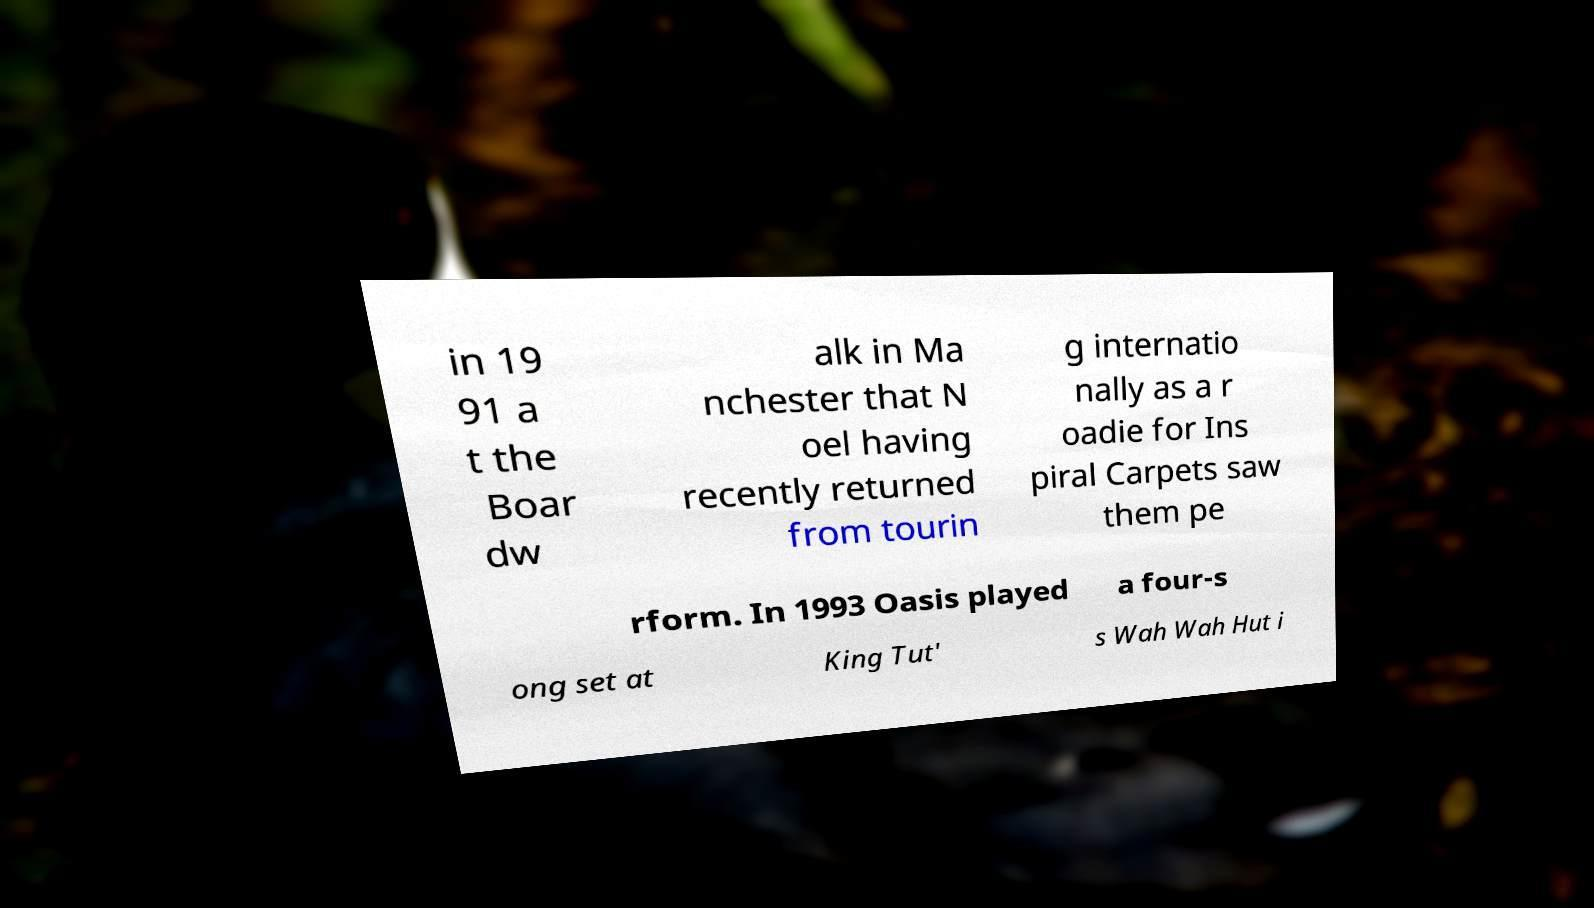Can you read and provide the text displayed in the image?This photo seems to have some interesting text. Can you extract and type it out for me? in 19 91 a t the Boar dw alk in Ma nchester that N oel having recently returned from tourin g internatio nally as a r oadie for Ins piral Carpets saw them pe rform. In 1993 Oasis played a four-s ong set at King Tut' s Wah Wah Hut i 